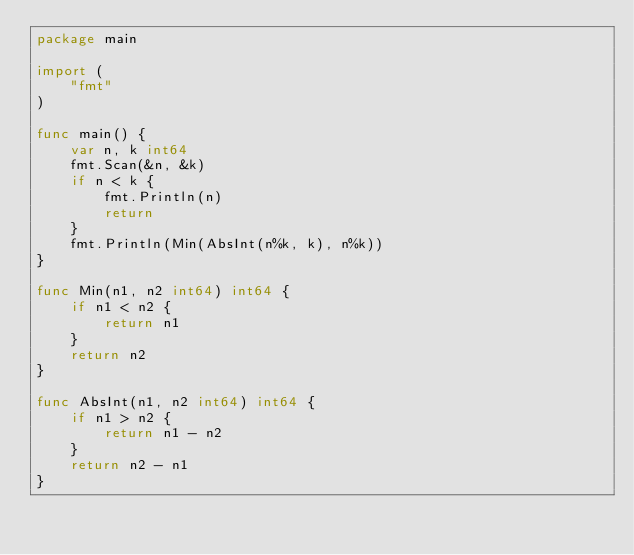Convert code to text. <code><loc_0><loc_0><loc_500><loc_500><_Go_>package main

import (
	"fmt"
)

func main() {
	var n, k int64
	fmt.Scan(&n, &k)
	if n < k {
		fmt.Println(n)
		return
	}
	fmt.Println(Min(AbsInt(n%k, k), n%k))
}

func Min(n1, n2 int64) int64 {
	if n1 < n2 {
		return n1
	}
	return n2
}

func AbsInt(n1, n2 int64) int64 {
	if n1 > n2 {
		return n1 - n2
	}
	return n2 - n1
}
</code> 